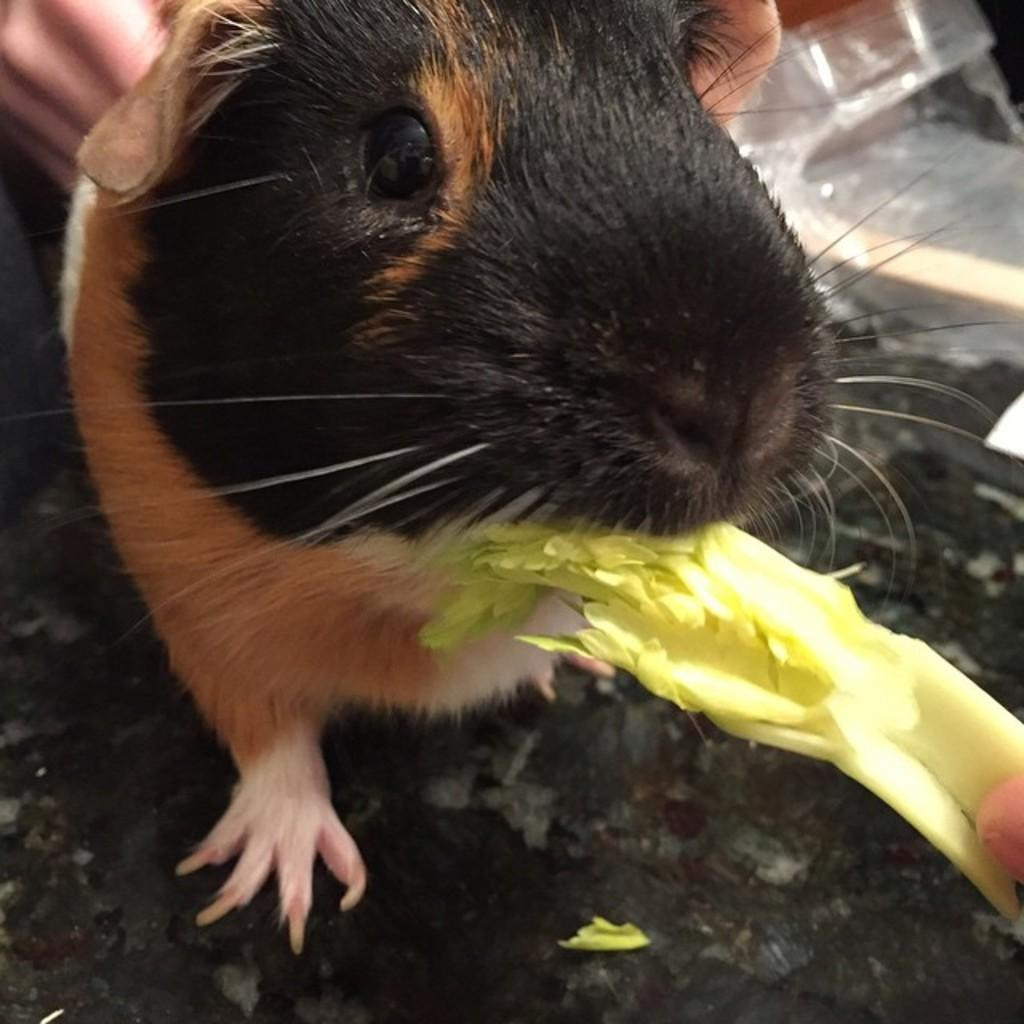What animal is the main subject of the picture? There is a rat in the picture. Can you describe the rat's coloring? The rat is black, brown, and white in color. What is the rat doing in the picture? The rat is eating veggies. Is there any human presence in the image? Yes, a human hand is visible in the picture. What type of stick can be seen in the rat's hand in the image? There is no stick present in the image, nor is there any indication that the rat has a hand. 